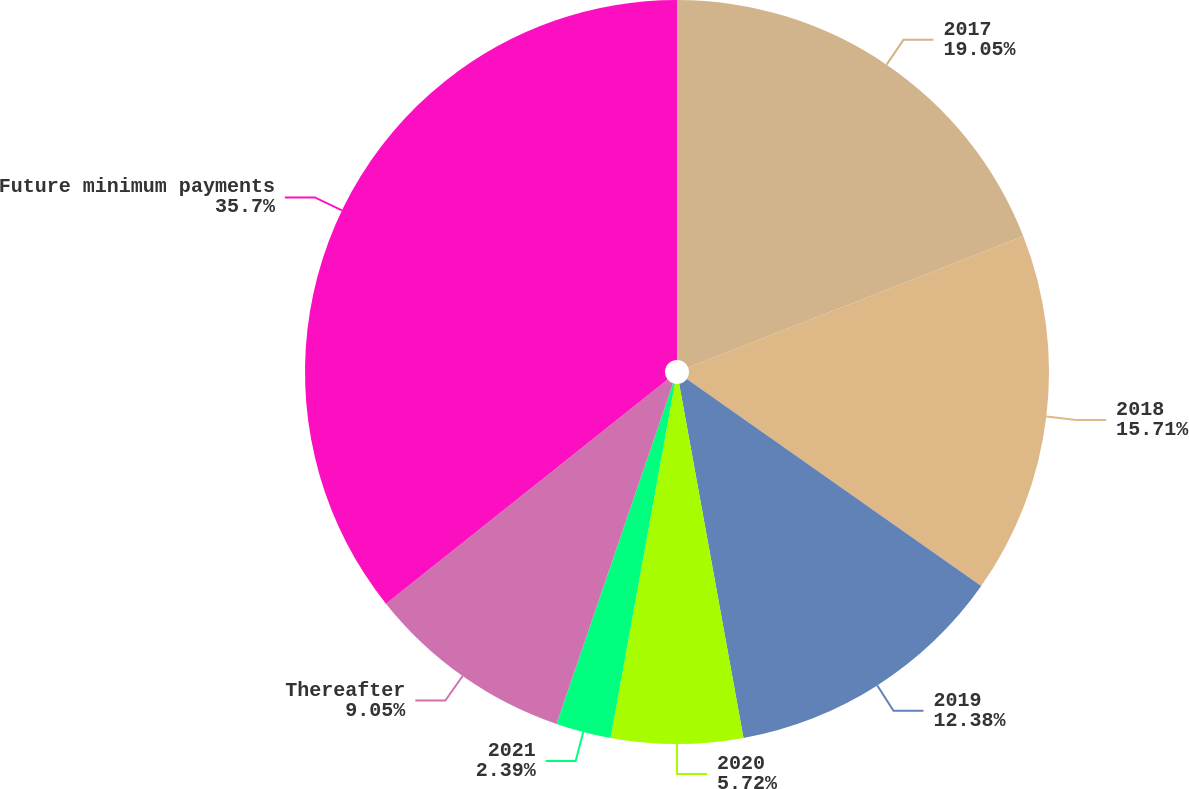<chart> <loc_0><loc_0><loc_500><loc_500><pie_chart><fcel>2017<fcel>2018<fcel>2019<fcel>2020<fcel>2021<fcel>Thereafter<fcel>Future minimum payments<nl><fcel>19.05%<fcel>15.71%<fcel>12.38%<fcel>5.72%<fcel>2.39%<fcel>9.05%<fcel>35.7%<nl></chart> 